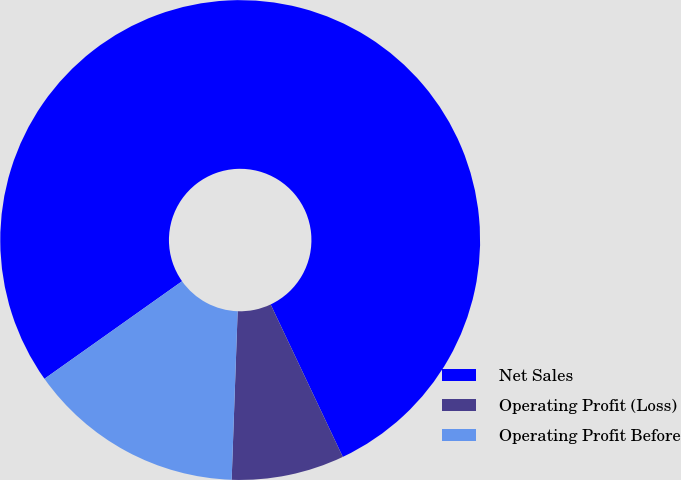<chart> <loc_0><loc_0><loc_500><loc_500><pie_chart><fcel>Net Sales<fcel>Operating Profit (Loss)<fcel>Operating Profit Before<nl><fcel>77.78%<fcel>7.6%<fcel>14.62%<nl></chart> 